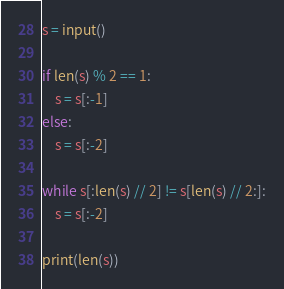<code> <loc_0><loc_0><loc_500><loc_500><_Python_>s = input()

if len(s) % 2 == 1:
    s = s[:-1]
else:
    s = s[:-2]

while s[:len(s) // 2] != s[len(s) // 2:]:
    s = s[:-2]

print(len(s))</code> 